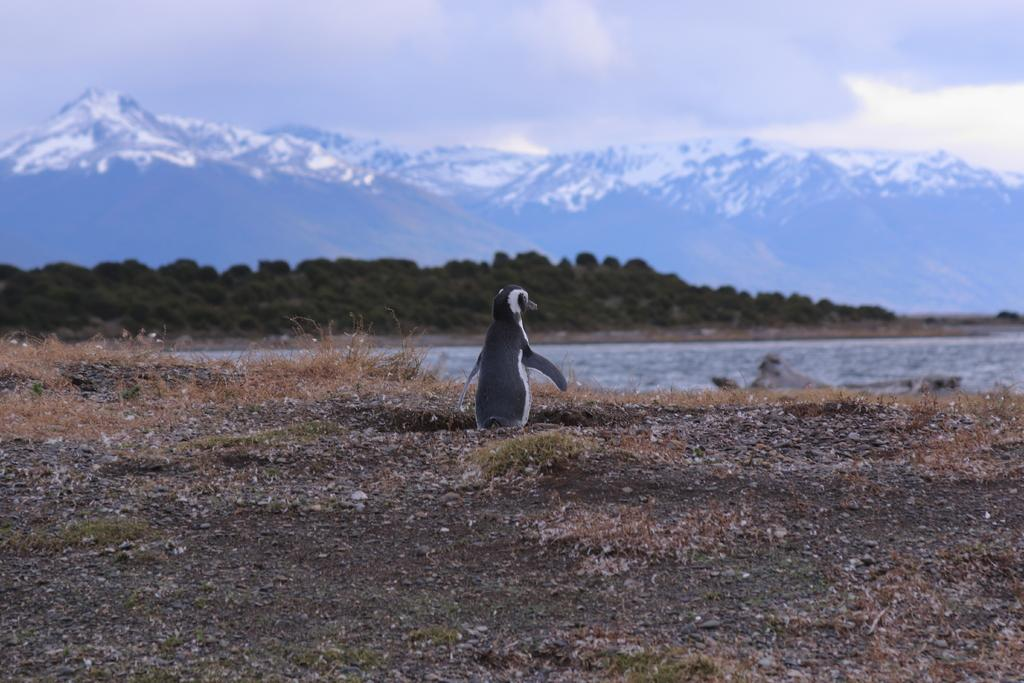What can be seen in the background of the image? There is sky and hills visible in the background of the image. What is visible in the image besides the sky and hills? There is water visible in the image. What type of animal is present in the image? There is a penguin in the image. Can you tell me how many wrens are flying over the hills in the image? There are no wrens present in the image. What type of army is visible in the image? There is no army present in the image. 